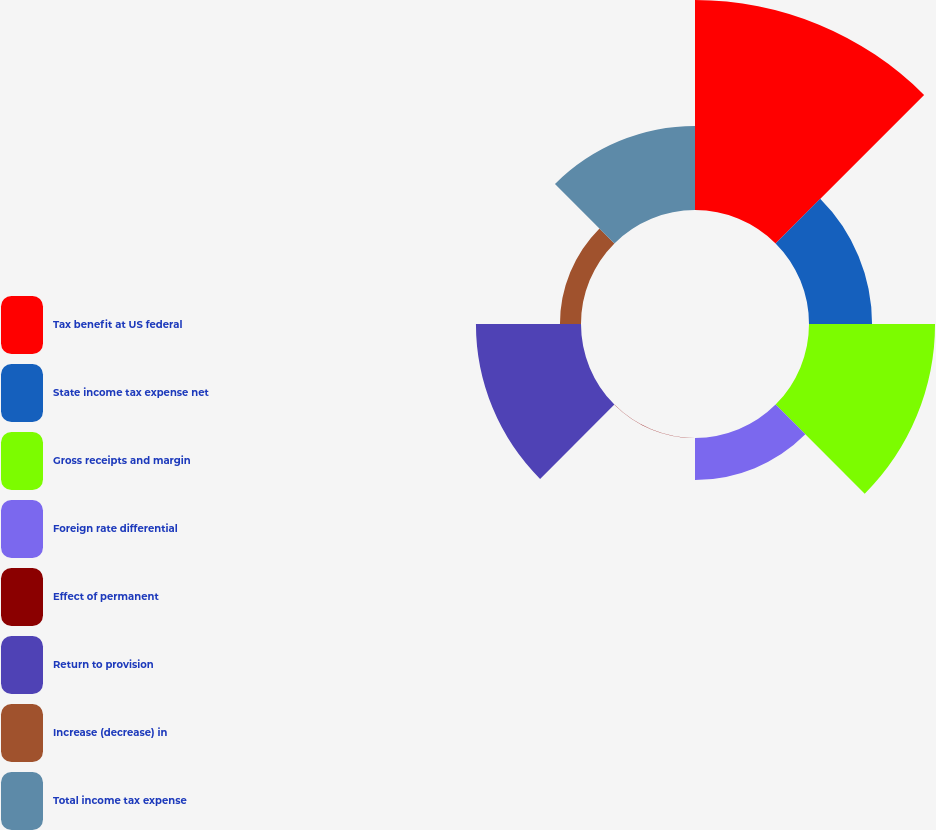Convert chart. <chart><loc_0><loc_0><loc_500><loc_500><pie_chart><fcel>Tax benefit at US federal<fcel>State income tax expense net<fcel>Gross receipts and margin<fcel>Foreign rate differential<fcel>Effect of permanent<fcel>Return to provision<fcel>Increase (decrease) in<fcel>Total income tax expense<nl><fcel>32.24%<fcel>9.68%<fcel>19.35%<fcel>6.46%<fcel>0.01%<fcel>16.13%<fcel>3.23%<fcel>12.9%<nl></chart> 